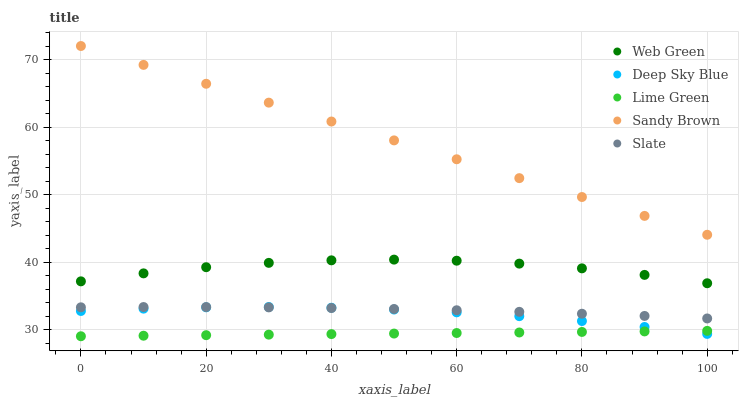Does Lime Green have the minimum area under the curve?
Answer yes or no. Yes. Does Sandy Brown have the maximum area under the curve?
Answer yes or no. Yes. Does Slate have the minimum area under the curve?
Answer yes or no. No. Does Slate have the maximum area under the curve?
Answer yes or no. No. Is Sandy Brown the smoothest?
Answer yes or no. Yes. Is Web Green the roughest?
Answer yes or no. Yes. Is Slate the smoothest?
Answer yes or no. No. Is Slate the roughest?
Answer yes or no. No. Does Lime Green have the lowest value?
Answer yes or no. Yes. Does Slate have the lowest value?
Answer yes or no. No. Does Sandy Brown have the highest value?
Answer yes or no. Yes. Does Slate have the highest value?
Answer yes or no. No. Is Slate less than Web Green?
Answer yes or no. Yes. Is Sandy Brown greater than Web Green?
Answer yes or no. Yes. Does Slate intersect Deep Sky Blue?
Answer yes or no. Yes. Is Slate less than Deep Sky Blue?
Answer yes or no. No. Is Slate greater than Deep Sky Blue?
Answer yes or no. No. Does Slate intersect Web Green?
Answer yes or no. No. 